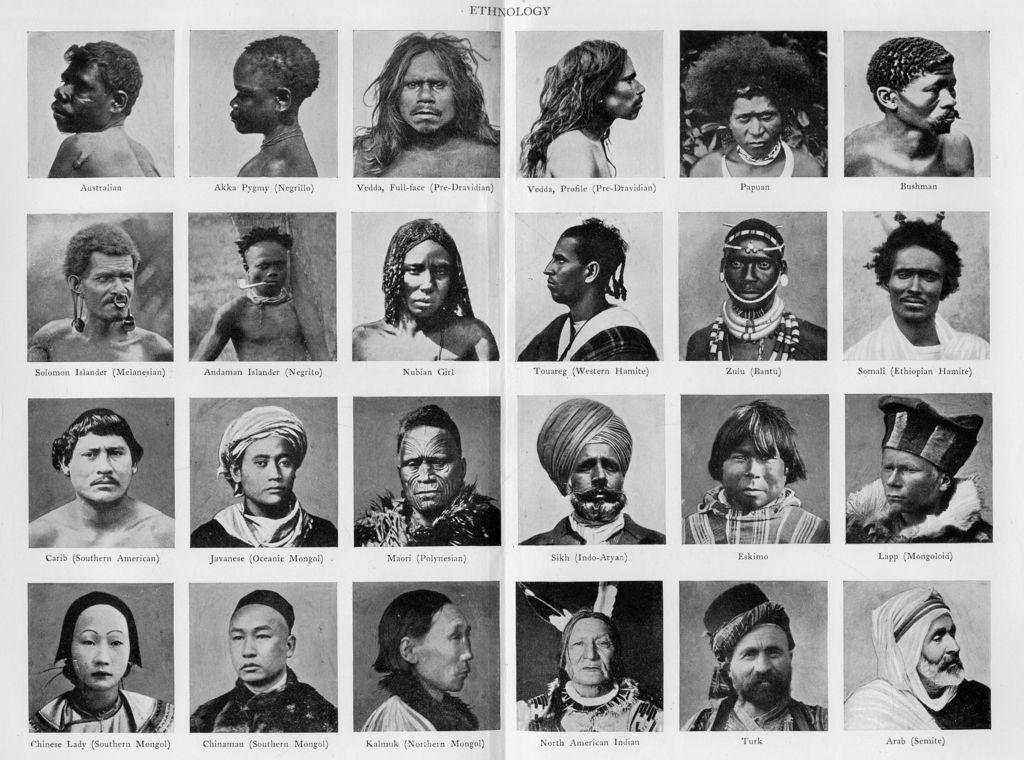What is the color scheme of the image? The image is black and white. What type of image is it? It is a collage of different people. Are there any labels or text in the image? Yes, the names of the people are present in the image. Can you see any beds in the image? There are no beds present in the image; it is a collage of different people. Is there a crown visible on any of the people in the image? There is no crown visible on any of the people in the image; it is a collage of different people without any accessories. 